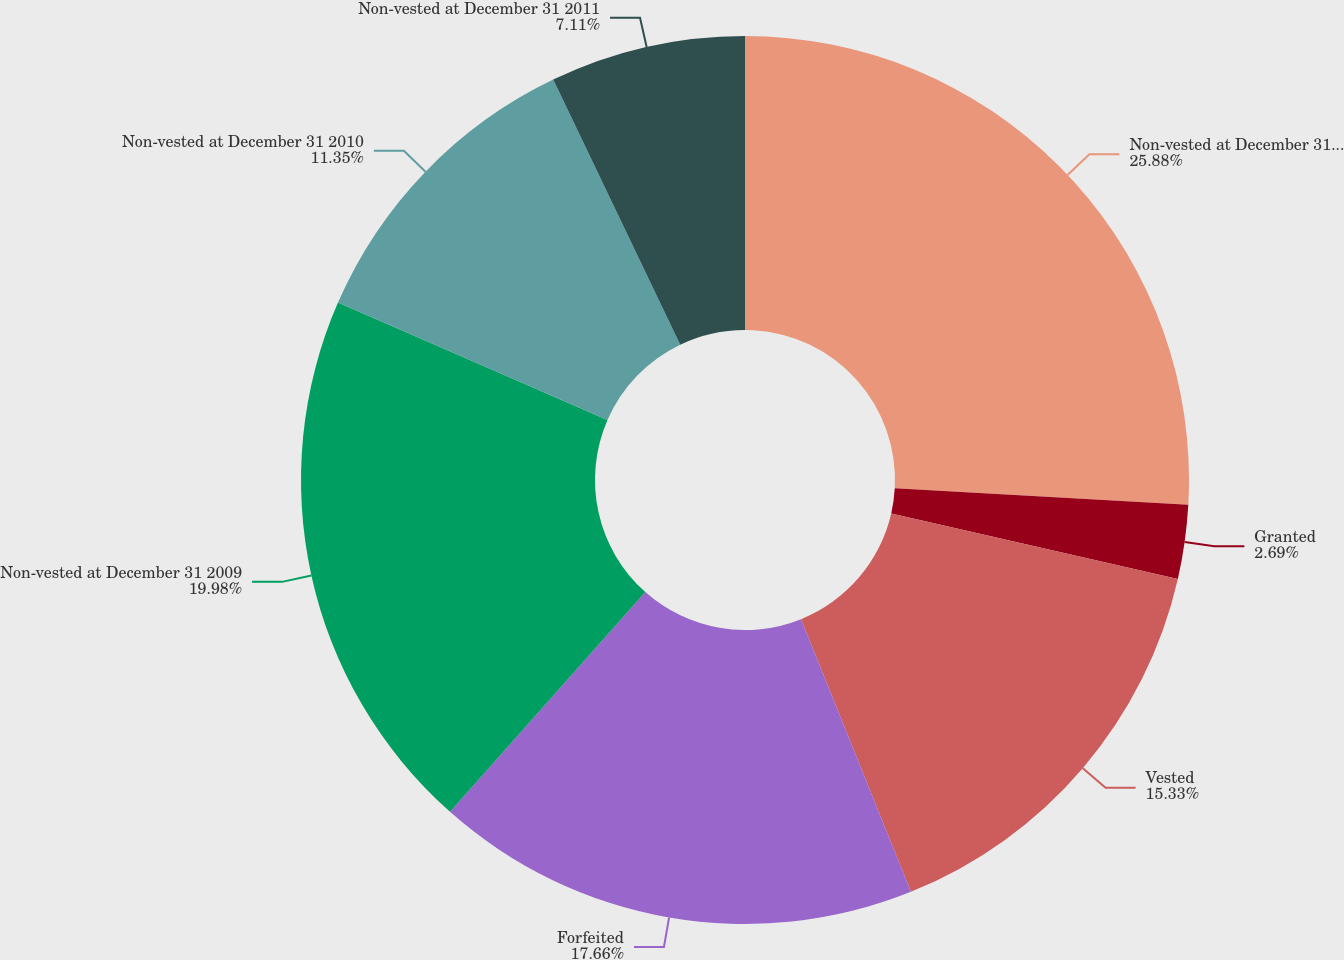<chart> <loc_0><loc_0><loc_500><loc_500><pie_chart><fcel>Non-vested at December 31 2008<fcel>Granted<fcel>Vested<fcel>Forfeited<fcel>Non-vested at December 31 2009<fcel>Non-vested at December 31 2010<fcel>Non-vested at December 31 2011<nl><fcel>25.89%<fcel>2.69%<fcel>15.33%<fcel>17.66%<fcel>19.98%<fcel>11.35%<fcel>7.11%<nl></chart> 